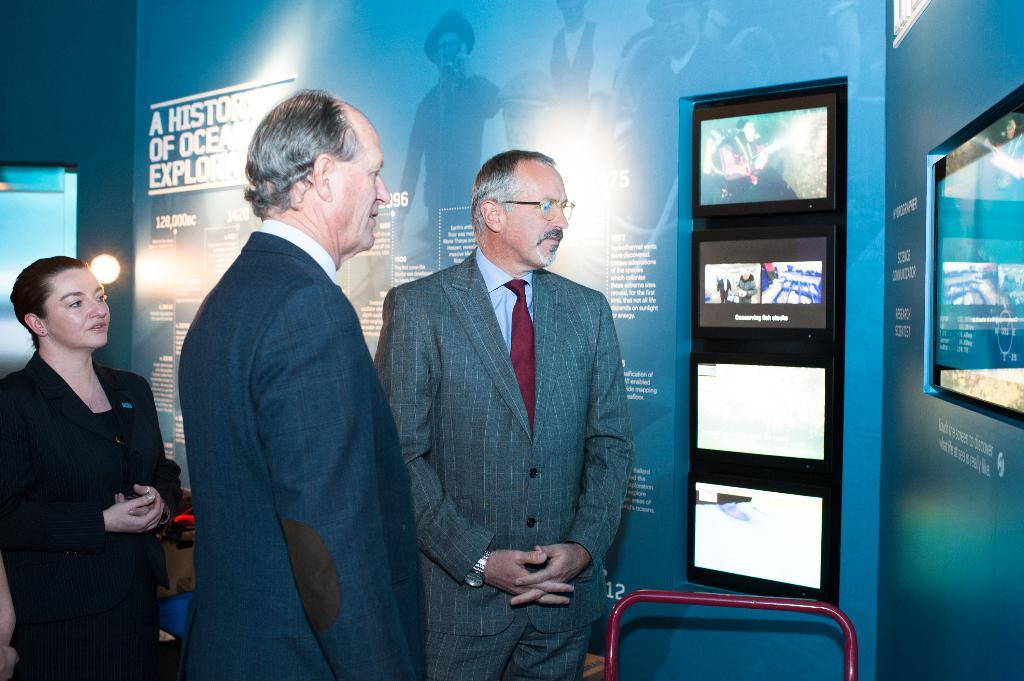How many people are in the image? There are three people in the image. What can be observed about the people's clothing? The people are wearing different color dresses. What objects are present in front of the people? There are many screens and boards in front of the people. Where is the light located in the image? There is a light visible to the left of the people. Are the three people in the image sisters? There is no information in the image to suggest that the three people are sisters. What type of paste is being used by the people in the image? There is no paste visible in the image, and no indication that the people are using any paste. 